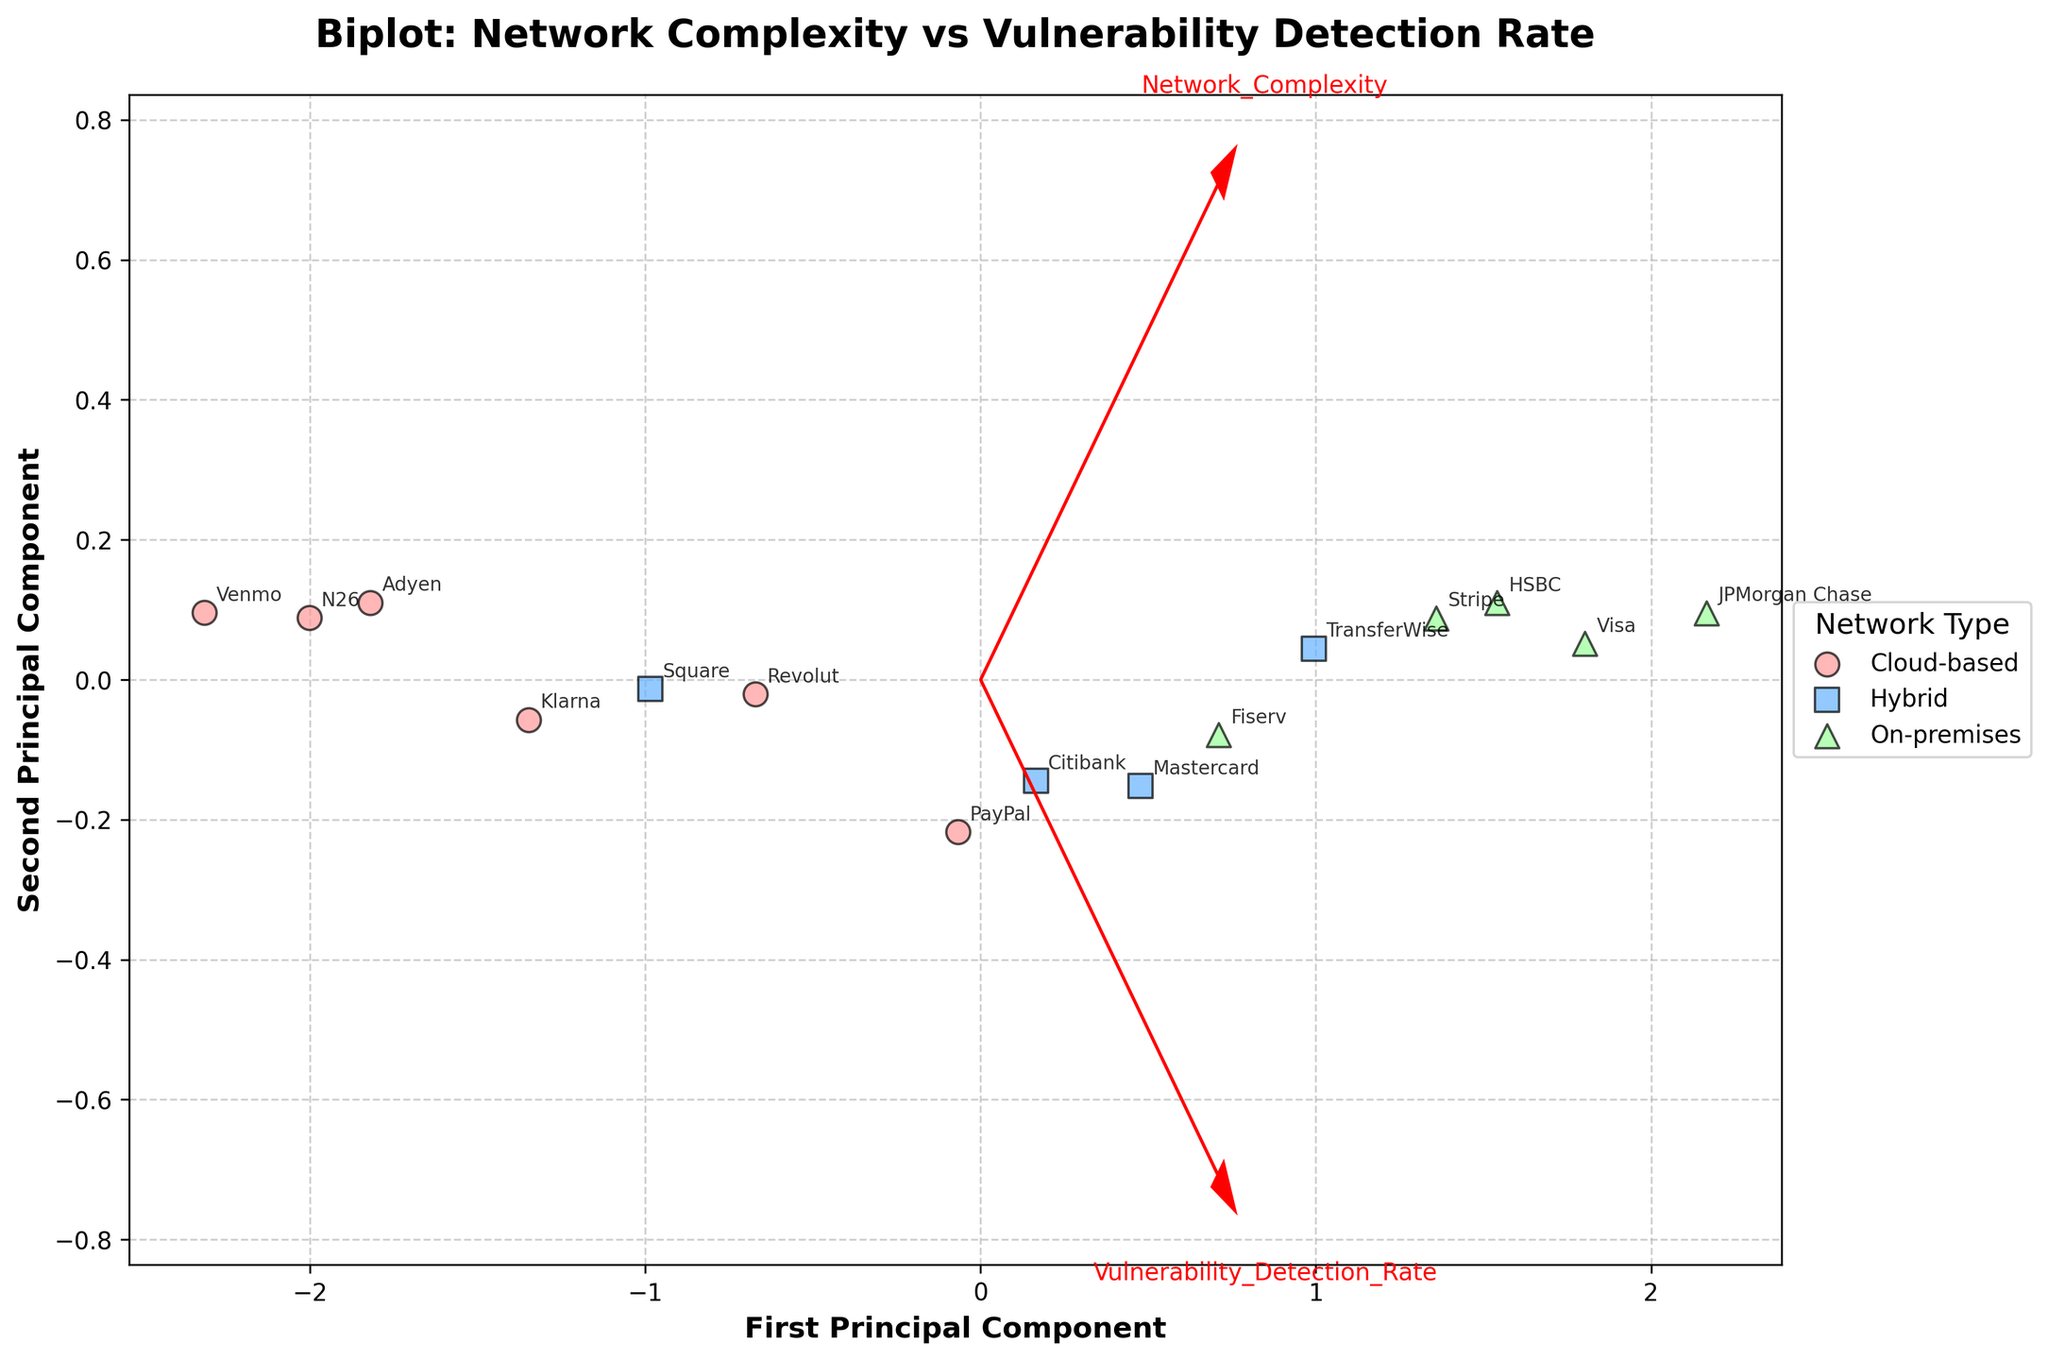What's the title of the figure? The title of the figure is prominently displayed at the top of the plot.
Answer: Biplot: Network Complexity vs Vulnerability Detection Rate How many companies were analyzed in this figure? Each data point in the figure represents a different company, and their names are annotated on the plot.
Answer: 15 Which network type has the highest vulnerability detection rate? By examining the colors and markers, we see JPMorgan Chase (On-premises, green) has the highest detection rate indicated by its position on the y-axis and annotation.
Answer: On-premises How do the cloud-based network types compare in terms of vulnerability detection rate? Looking at the red dots (Cloud-based) scattered across the plot and their positions along the y-axis, we can observe the variability in detection rates.
Answer: They have a variability ranging from 69 to 85 What's the unique characteristic of the On-premises network type shown in the plot? By observing the colors and markers, On-premises networks are shown with triangles and have the highest overall detection rates clustering on the right-hand side.
Answer: They generally have higher vulnerability detection rates Which company has the lowest network complexity? The value of network complexity is indicated on the x-axis, and from annotations, Venmo is farthest to the left.
Answer: Venmo Is there a noticeable trend between network complexity and detection rate? The arrows indicate the direction of the components; the general trend can be inferred from how data points with higher complexity align, shifting upward in detection rate.
Answer: Higher complexity shows a trend toward higher detection rates What does the first principal component represent in this figure? The direction and length of arrows help identify that the first principal component captures a mix of both network complexity and vulnerability detection rate.
Answer: A combination of network complexity and detection rate Which two network types show overlapping characteristics? By looking at the color clusters and markers, Hybrid and Cloud-based networks intermingle, indicating overlaps in complexity and detection rates.
Answer: Hybrid and Cloud-based How does the vulnerability detection rate for Hybrid networks compare with others? The blue squares (Hybrid) are spread but show generally higher detection rates compared to Cloud-based and less than On-premises.
Answer: Generally higher than Cloud-based but less than On-premises 